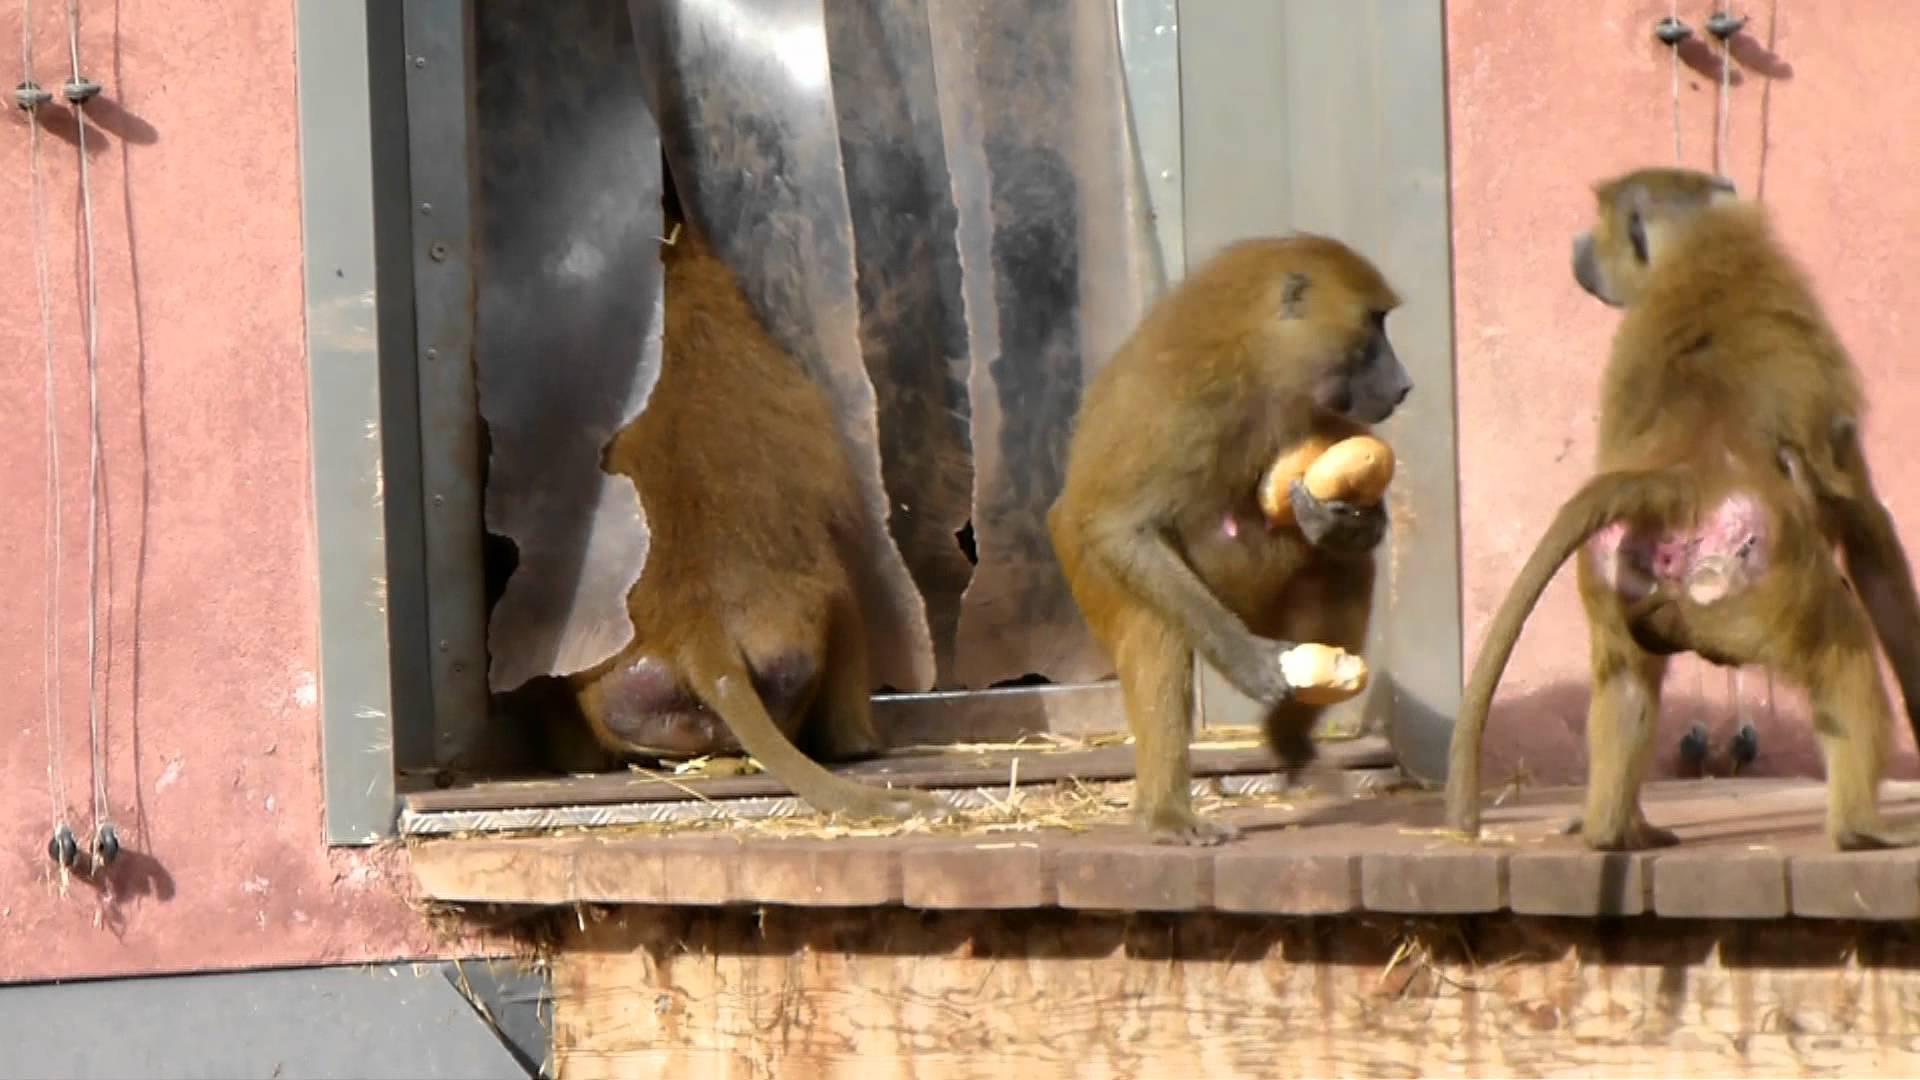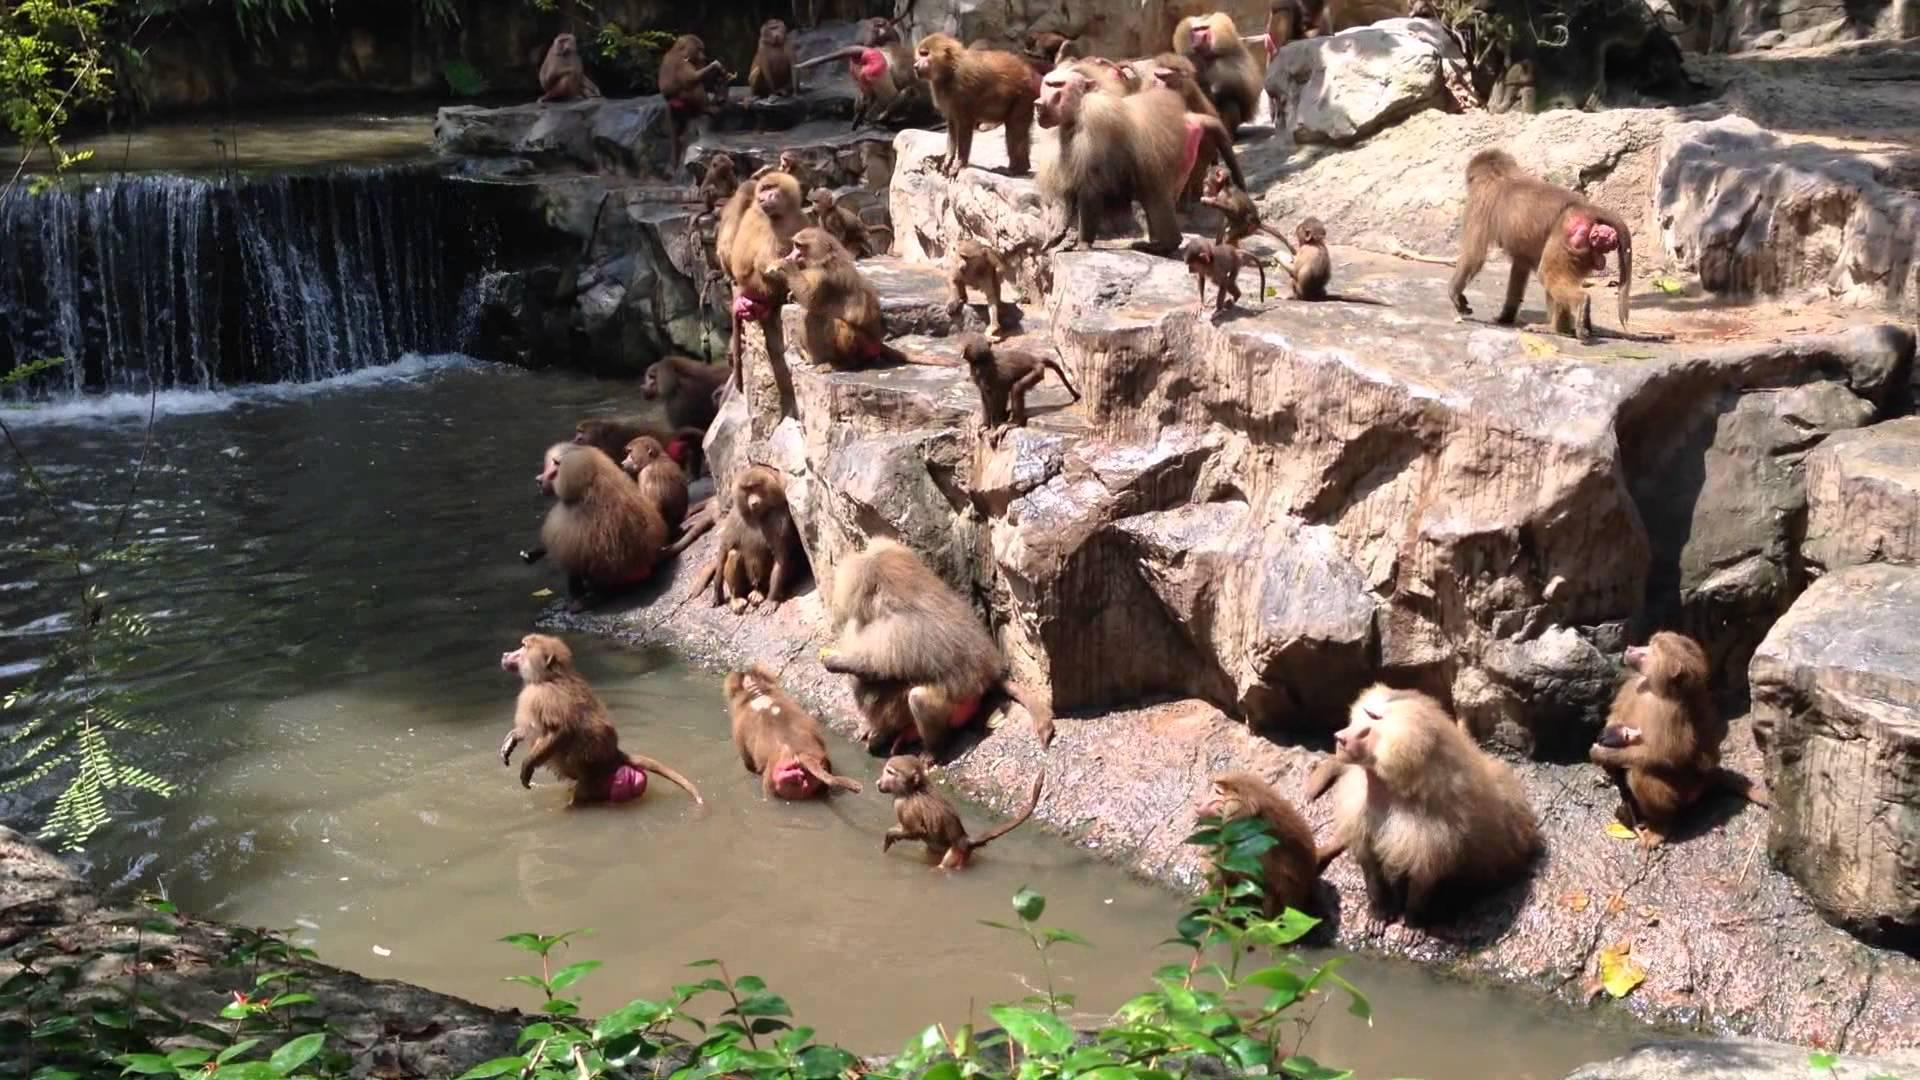The first image is the image on the left, the second image is the image on the right. Considering the images on both sides, is "In the image to the right, there are less than six animals." valid? Answer yes or no. No. The first image is the image on the left, the second image is the image on the right. Examine the images to the left and right. Is the description "An image shows a horizontal row of no more than four baboons of the same size, crouching with some food." accurate? Answer yes or no. Yes. 